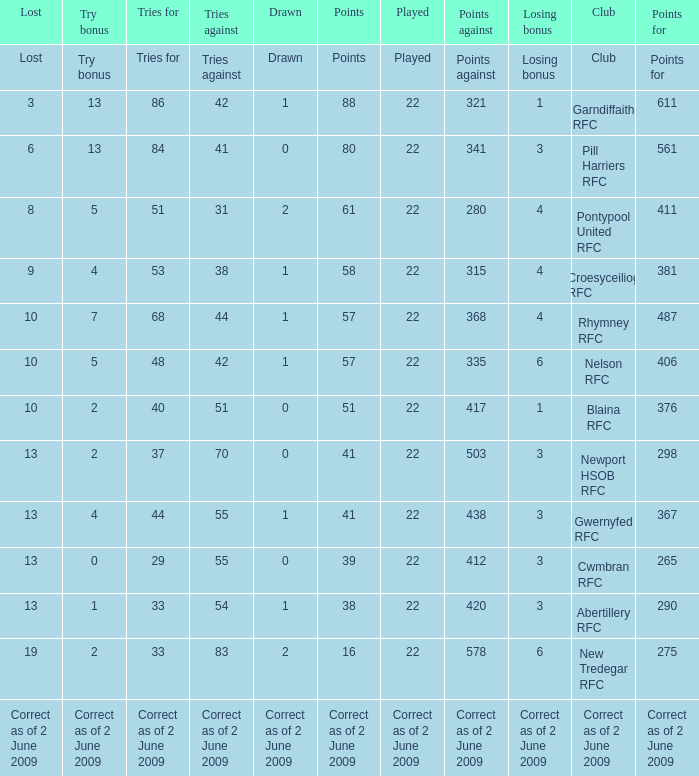How many tries did the club with a try bonus of correct as of 2 June 2009 have? Correct as of 2 June 2009. 